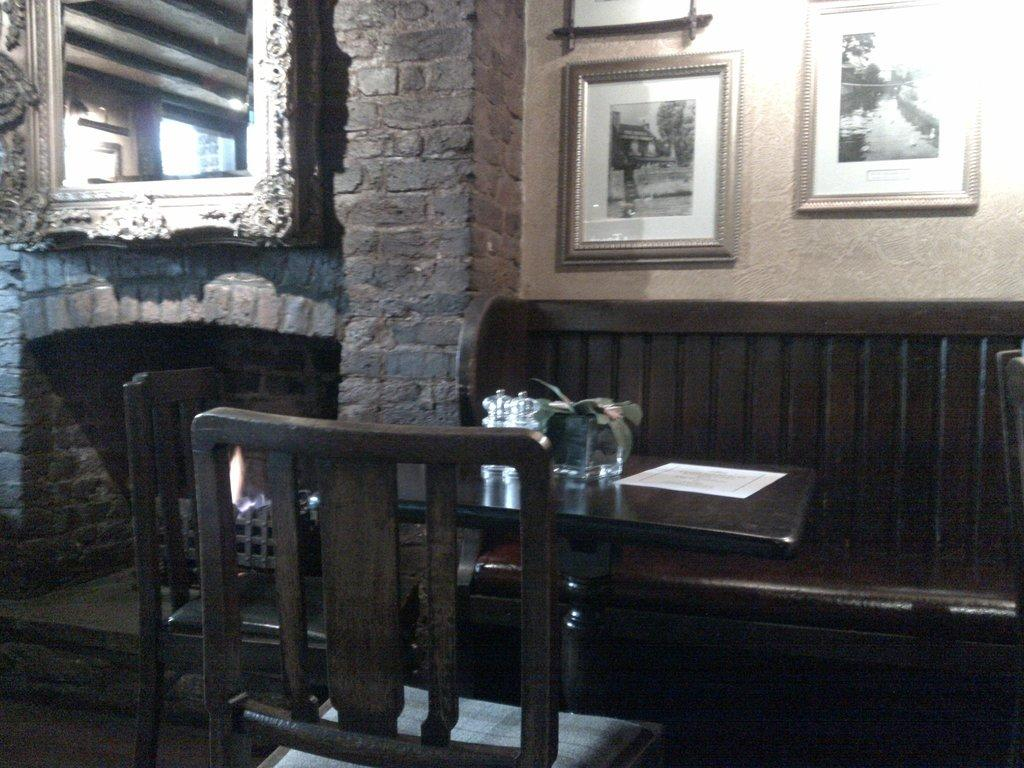What can be seen on the wall in the image? There are pictures on the wall. What type of furniture is present in the image? There is a table and chairs in the image. What is on the table in the image? There is a plant, a jar, and a paper on the table. What type of veil is draped over the plant on the table? There is no veil present on the plant or anywhere else in the image. What type of grape is visible in the jar on the table? There is no grape present in the jar or anywhere else in the image. 